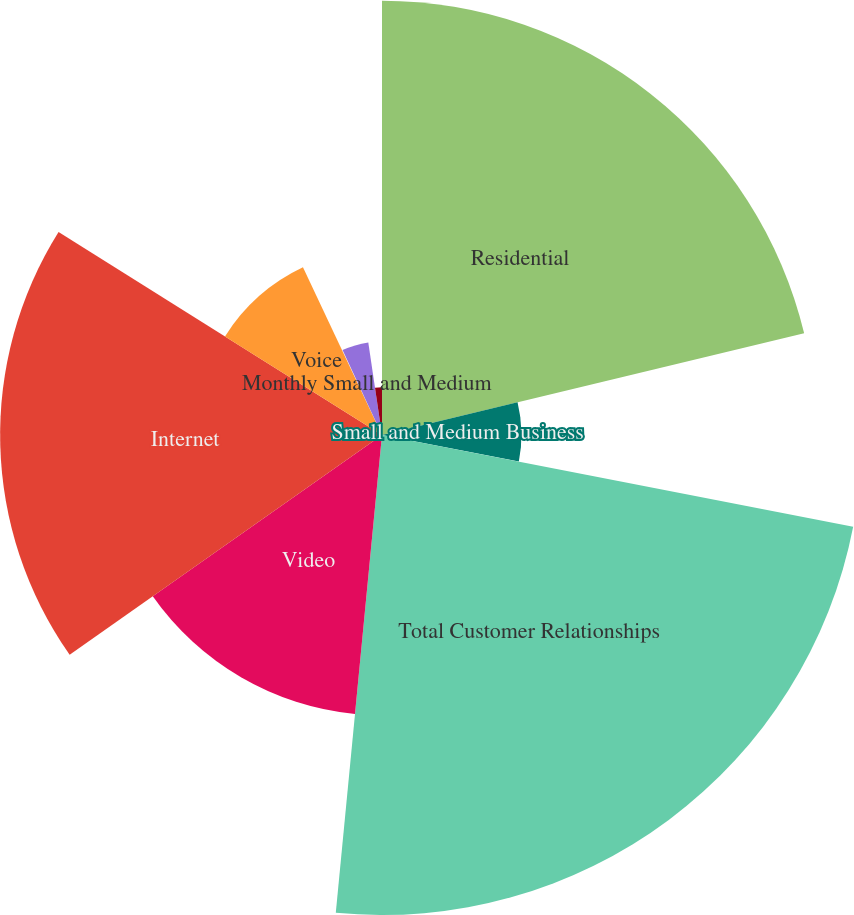<chart> <loc_0><loc_0><loc_500><loc_500><pie_chart><fcel>Residential<fcel>Small and Medium Business<fcel>Total Customer Relationships<fcel>Video<fcel>Internet<fcel>Voice<fcel>Monthly Residential Revenue<fcel>Monthly Small and Medium<fcel>Enterprise PSUs (f)<nl><fcel>21.24%<fcel>6.82%<fcel>23.48%<fcel>13.71%<fcel>18.68%<fcel>9.07%<fcel>0.09%<fcel>4.58%<fcel>2.34%<nl></chart> 